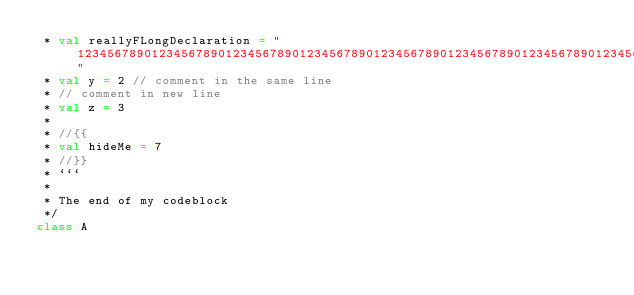Convert code to text. <code><loc_0><loc_0><loc_500><loc_500><_Scala_> * val reallyFLongDeclaration = "1234567890123456789012345678901234567890123456789012345678901234567890123456789012345678901234567890123456789012345678901234567890123456789012345678901234567890"
 * val y = 2 // comment in the same line
 * // comment in new line
 * val z = 3
 * 
 * //{{
 * val hideMe = 7
 * //}}
 * ```
 *
 * The end of my codeblock
 */
class A
</code> 